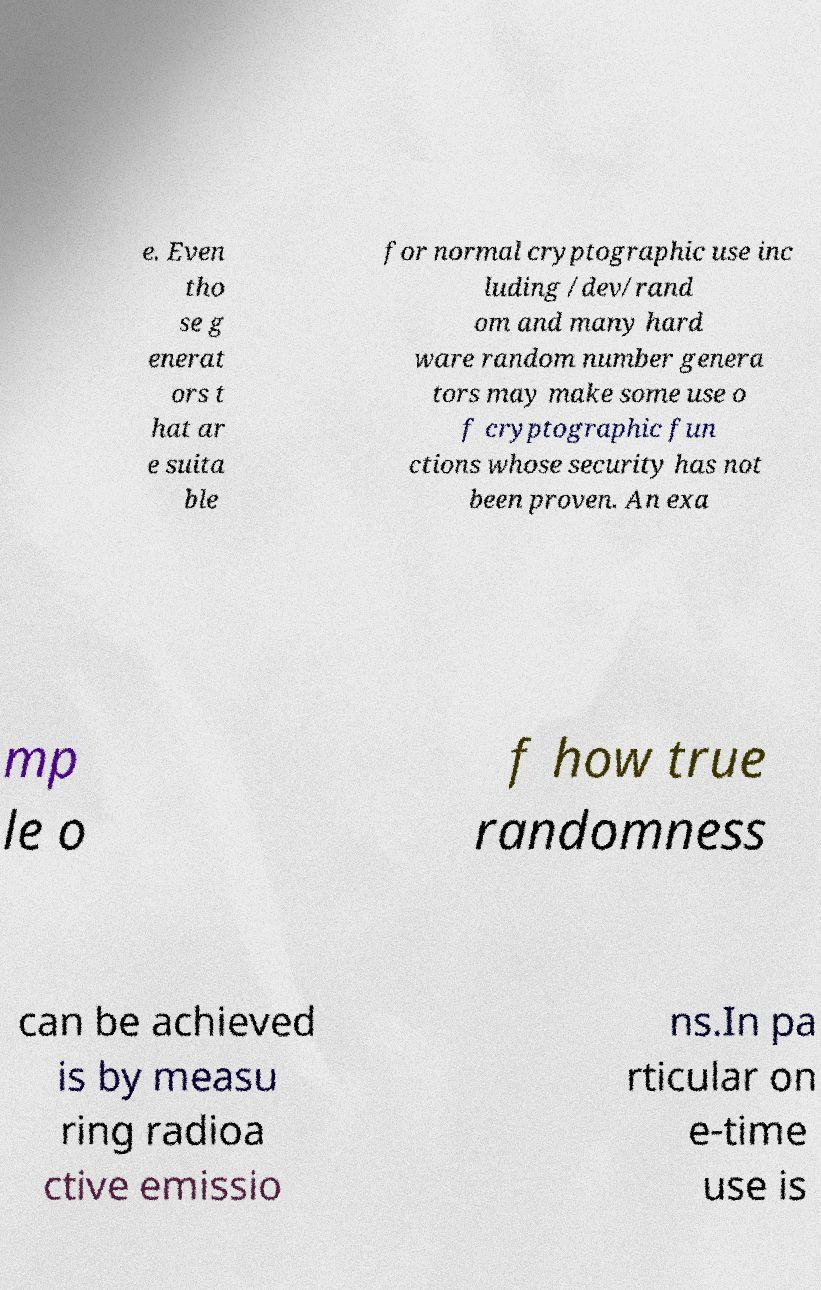Could you extract and type out the text from this image? e. Even tho se g enerat ors t hat ar e suita ble for normal cryptographic use inc luding /dev/rand om and many hard ware random number genera tors may make some use o f cryptographic fun ctions whose security has not been proven. An exa mp le o f how true randomness can be achieved is by measu ring radioa ctive emissio ns.In pa rticular on e-time use is 